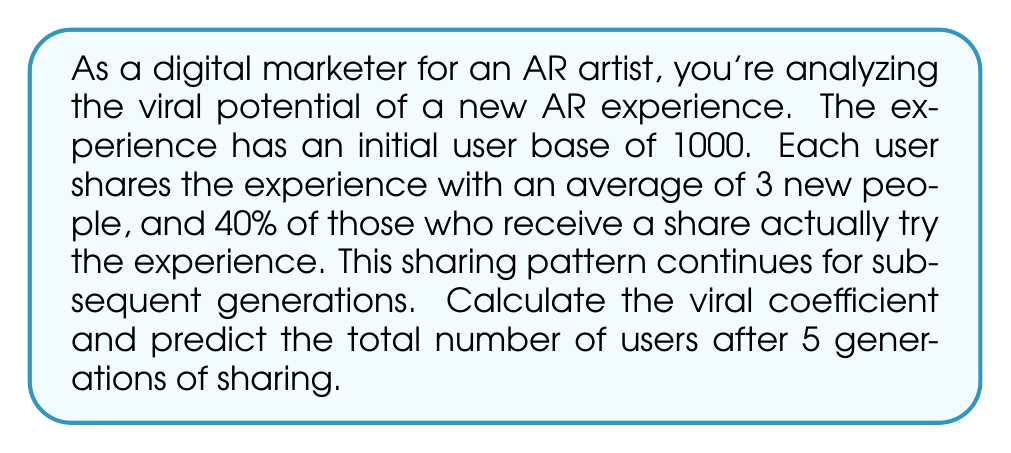Can you solve this math problem? Let's approach this step-by-step:

1) First, we need to calculate the viral coefficient (k).
   The viral coefficient is the number of new users each existing user generates.
   
   $k = \text{shares per user} \times \text{conversion rate}$
   $k = 3 \times 0.40 = 1.2$

2) Now, let's calculate the number of new users in each generation:
   
   Generation 1: $1000 \times 1.2 = 1200$ new users
   Generation 2: $1200 \times 1.2 = 1440$ new users
   Generation 3: $1440 \times 1.2 = 1728$ new users
   Generation 4: $1728 \times 1.2 = 2073.6 \approx 2074$ new users
   Generation 5: $2074 \times 1.2 = 2488.8 \approx 2489$ new users

3) To find the total number of users after 5 generations, we sum the initial users and all new users:

   $\text{Total} = 1000 + 1200 + 1440 + 1728 + 2074 + 2489 = 9931$

4) We can verify this using the formula for the sum of a geometric series:

   $$S_n = a\frac{1-r^n}{1-r}$$

   Where $a$ is the initial number of users, $r$ is the viral coefficient, and $n$ is the number of generations.

   $$S_5 = 1000\frac{1-1.2^5}{1-1.2} = 1000\frac{1-2.48832}{-0.2} = 9931.6$$

   This confirms our step-by-step calculation (with a small difference due to rounding).
Answer: The viral coefficient is 1.2, and the total number of users after 5 generations of sharing is approximately 9,932. 